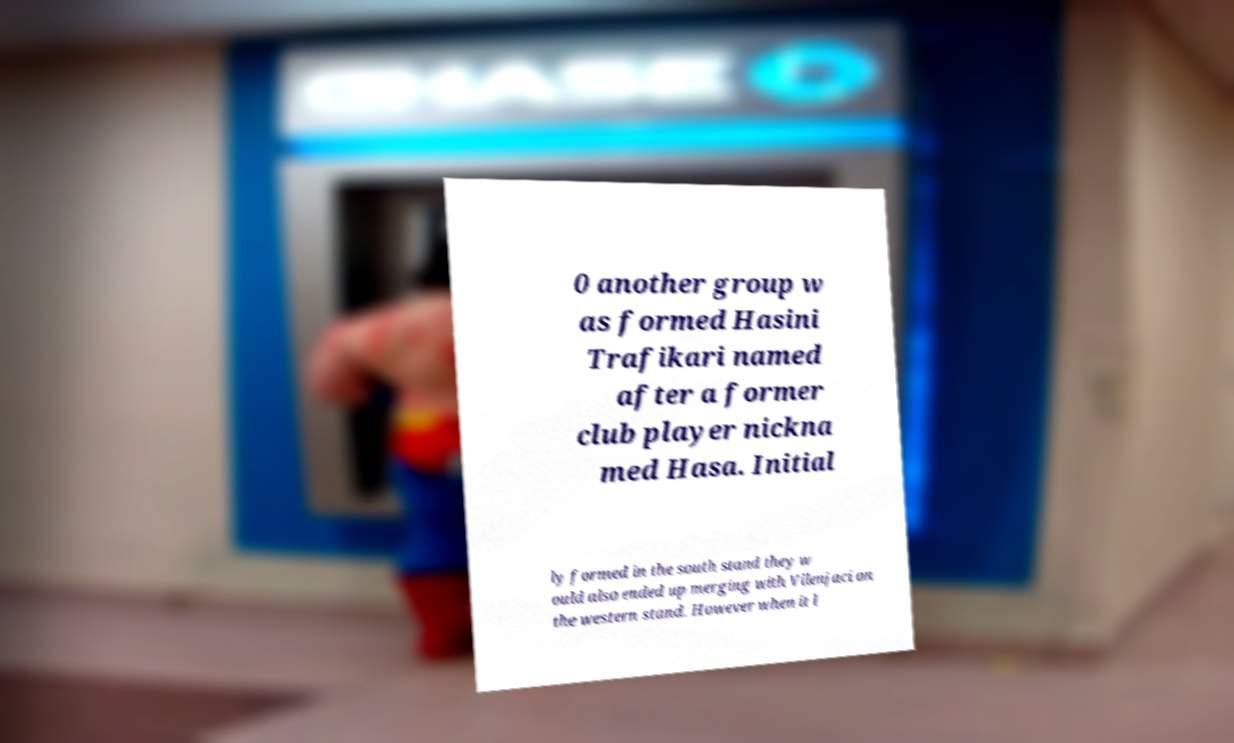I need the written content from this picture converted into text. Can you do that? 0 another group w as formed Hasini Trafikari named after a former club player nickna med Hasa. Initial ly formed in the south stand they w ould also ended up merging with Vilenjaci on the western stand. However when it l 